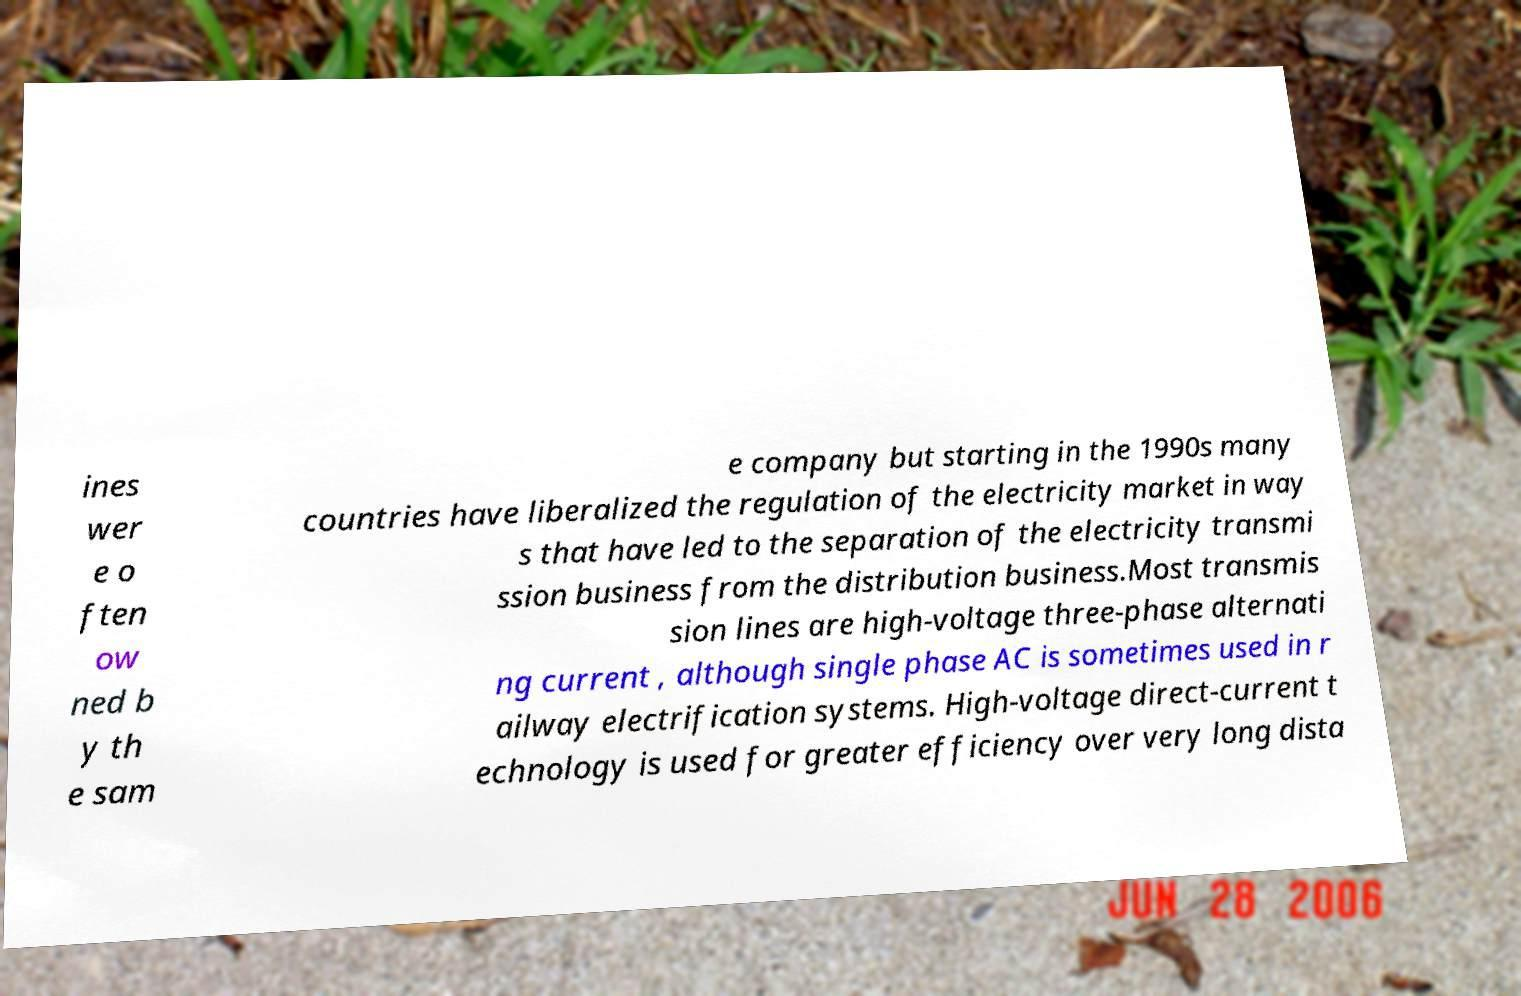What messages or text are displayed in this image? I need them in a readable, typed format. ines wer e o ften ow ned b y th e sam e company but starting in the 1990s many countries have liberalized the regulation of the electricity market in way s that have led to the separation of the electricity transmi ssion business from the distribution business.Most transmis sion lines are high-voltage three-phase alternati ng current , although single phase AC is sometimes used in r ailway electrification systems. High-voltage direct-current t echnology is used for greater efficiency over very long dista 